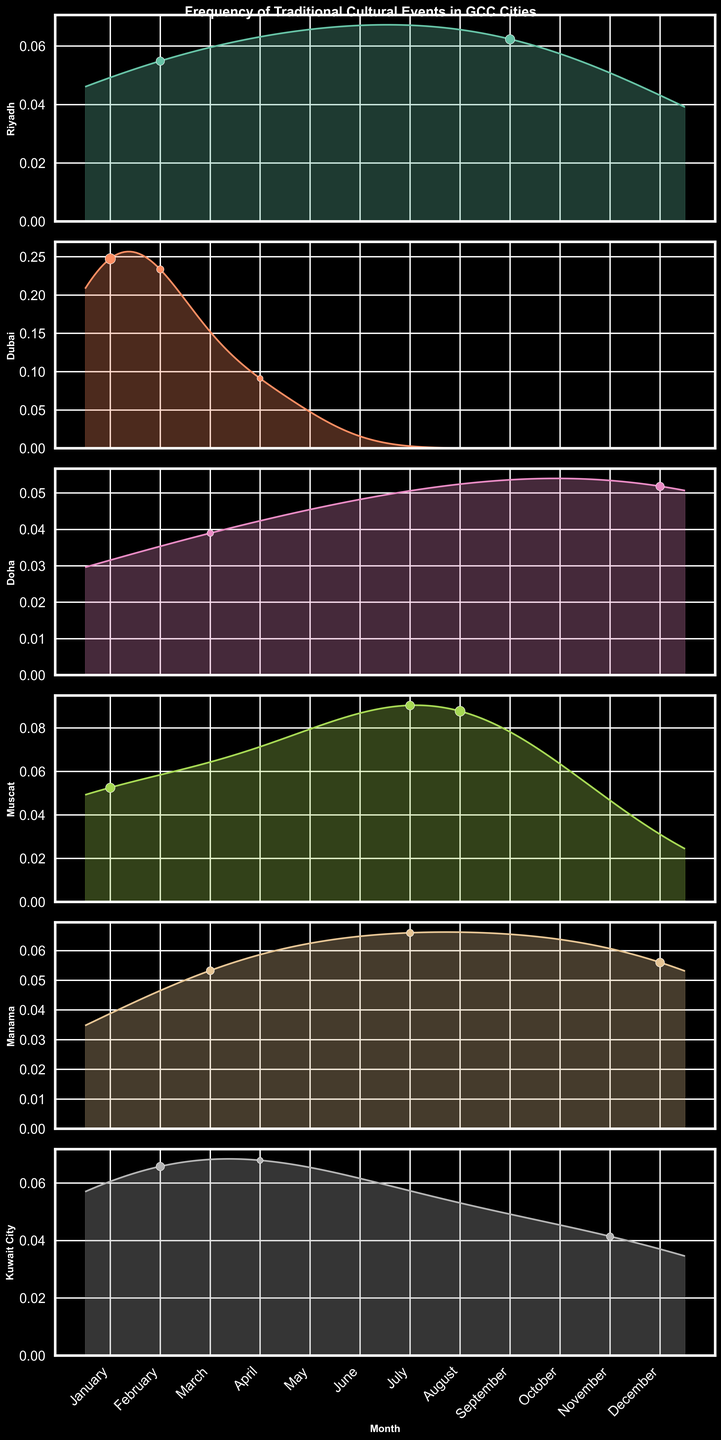What is the title of the figure? The title is displayed at the top of the figure in bold text.
Answer: Frequency of Traditional Cultural Events in GCC Cities Which city shows the highest peak frequency density in January? By observing the density plots, the highest peak in January is indicated by the tallest curve.
Answer: Dubai How does the frequency of cultural events in Muscat in July compare to other months? In July, Muscat has a significant peak due to the Khareef Festival. Comparing its density to other months shows it's one of the highest.
Answer: Higher Which city has cultural events occurring in the months variable by lunar calendar? The figure shows events with scattered points outside the fixed monthly bins, indicating moons.
Answer: Riyadh and Doha In which month does Doha have its peak density? By identifying the highest point in Doha’s density plot, we can determine the peak month.
Answer: December Which cities have a notable number of events in February? Cities with higher density or larger scatter points in February can be observed.
Answer: Riyadh, Dubai, and Kuwait City Compare the density of cultural events in Manama in March and July. Which is higher? By comparing the heights of the density curves for March and July in Manama’s plot, we can see which month has higher density.
Answer: March What can you infer about the distribution of cultural events in Riyadh throughout the year? By examining Riyadh's density plot and scatter points, we see events are spread across many months but show peaks in specific times.
Answer: Scattered with peaks Which month shows the lowest density for Dubai? We look for the month with the smallest density curve or no scatters in Dubai’s plot.
Answer: May Is there a city with a uniform distribution of events throughout the year? Check each city's density plot for even distribution. All plots show variability with peaks, no city displays a uniform distribution.
Answer: No 